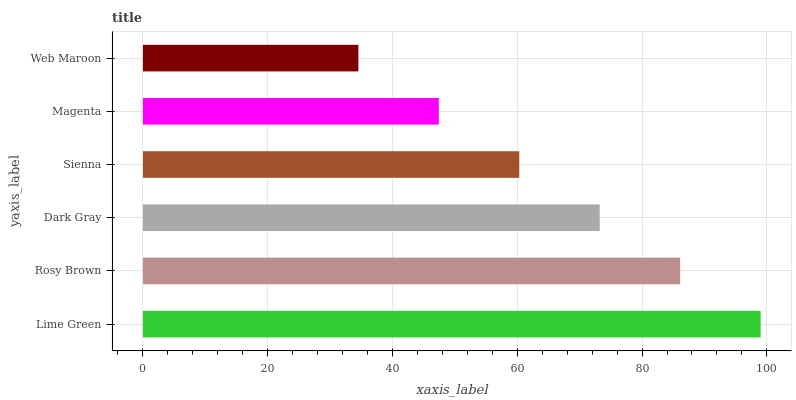Is Web Maroon the minimum?
Answer yes or no. Yes. Is Lime Green the maximum?
Answer yes or no. Yes. Is Rosy Brown the minimum?
Answer yes or no. No. Is Rosy Brown the maximum?
Answer yes or no. No. Is Lime Green greater than Rosy Brown?
Answer yes or no. Yes. Is Rosy Brown less than Lime Green?
Answer yes or no. Yes. Is Rosy Brown greater than Lime Green?
Answer yes or no. No. Is Lime Green less than Rosy Brown?
Answer yes or no. No. Is Dark Gray the high median?
Answer yes or no. Yes. Is Sienna the low median?
Answer yes or no. Yes. Is Magenta the high median?
Answer yes or no. No. Is Lime Green the low median?
Answer yes or no. No. 